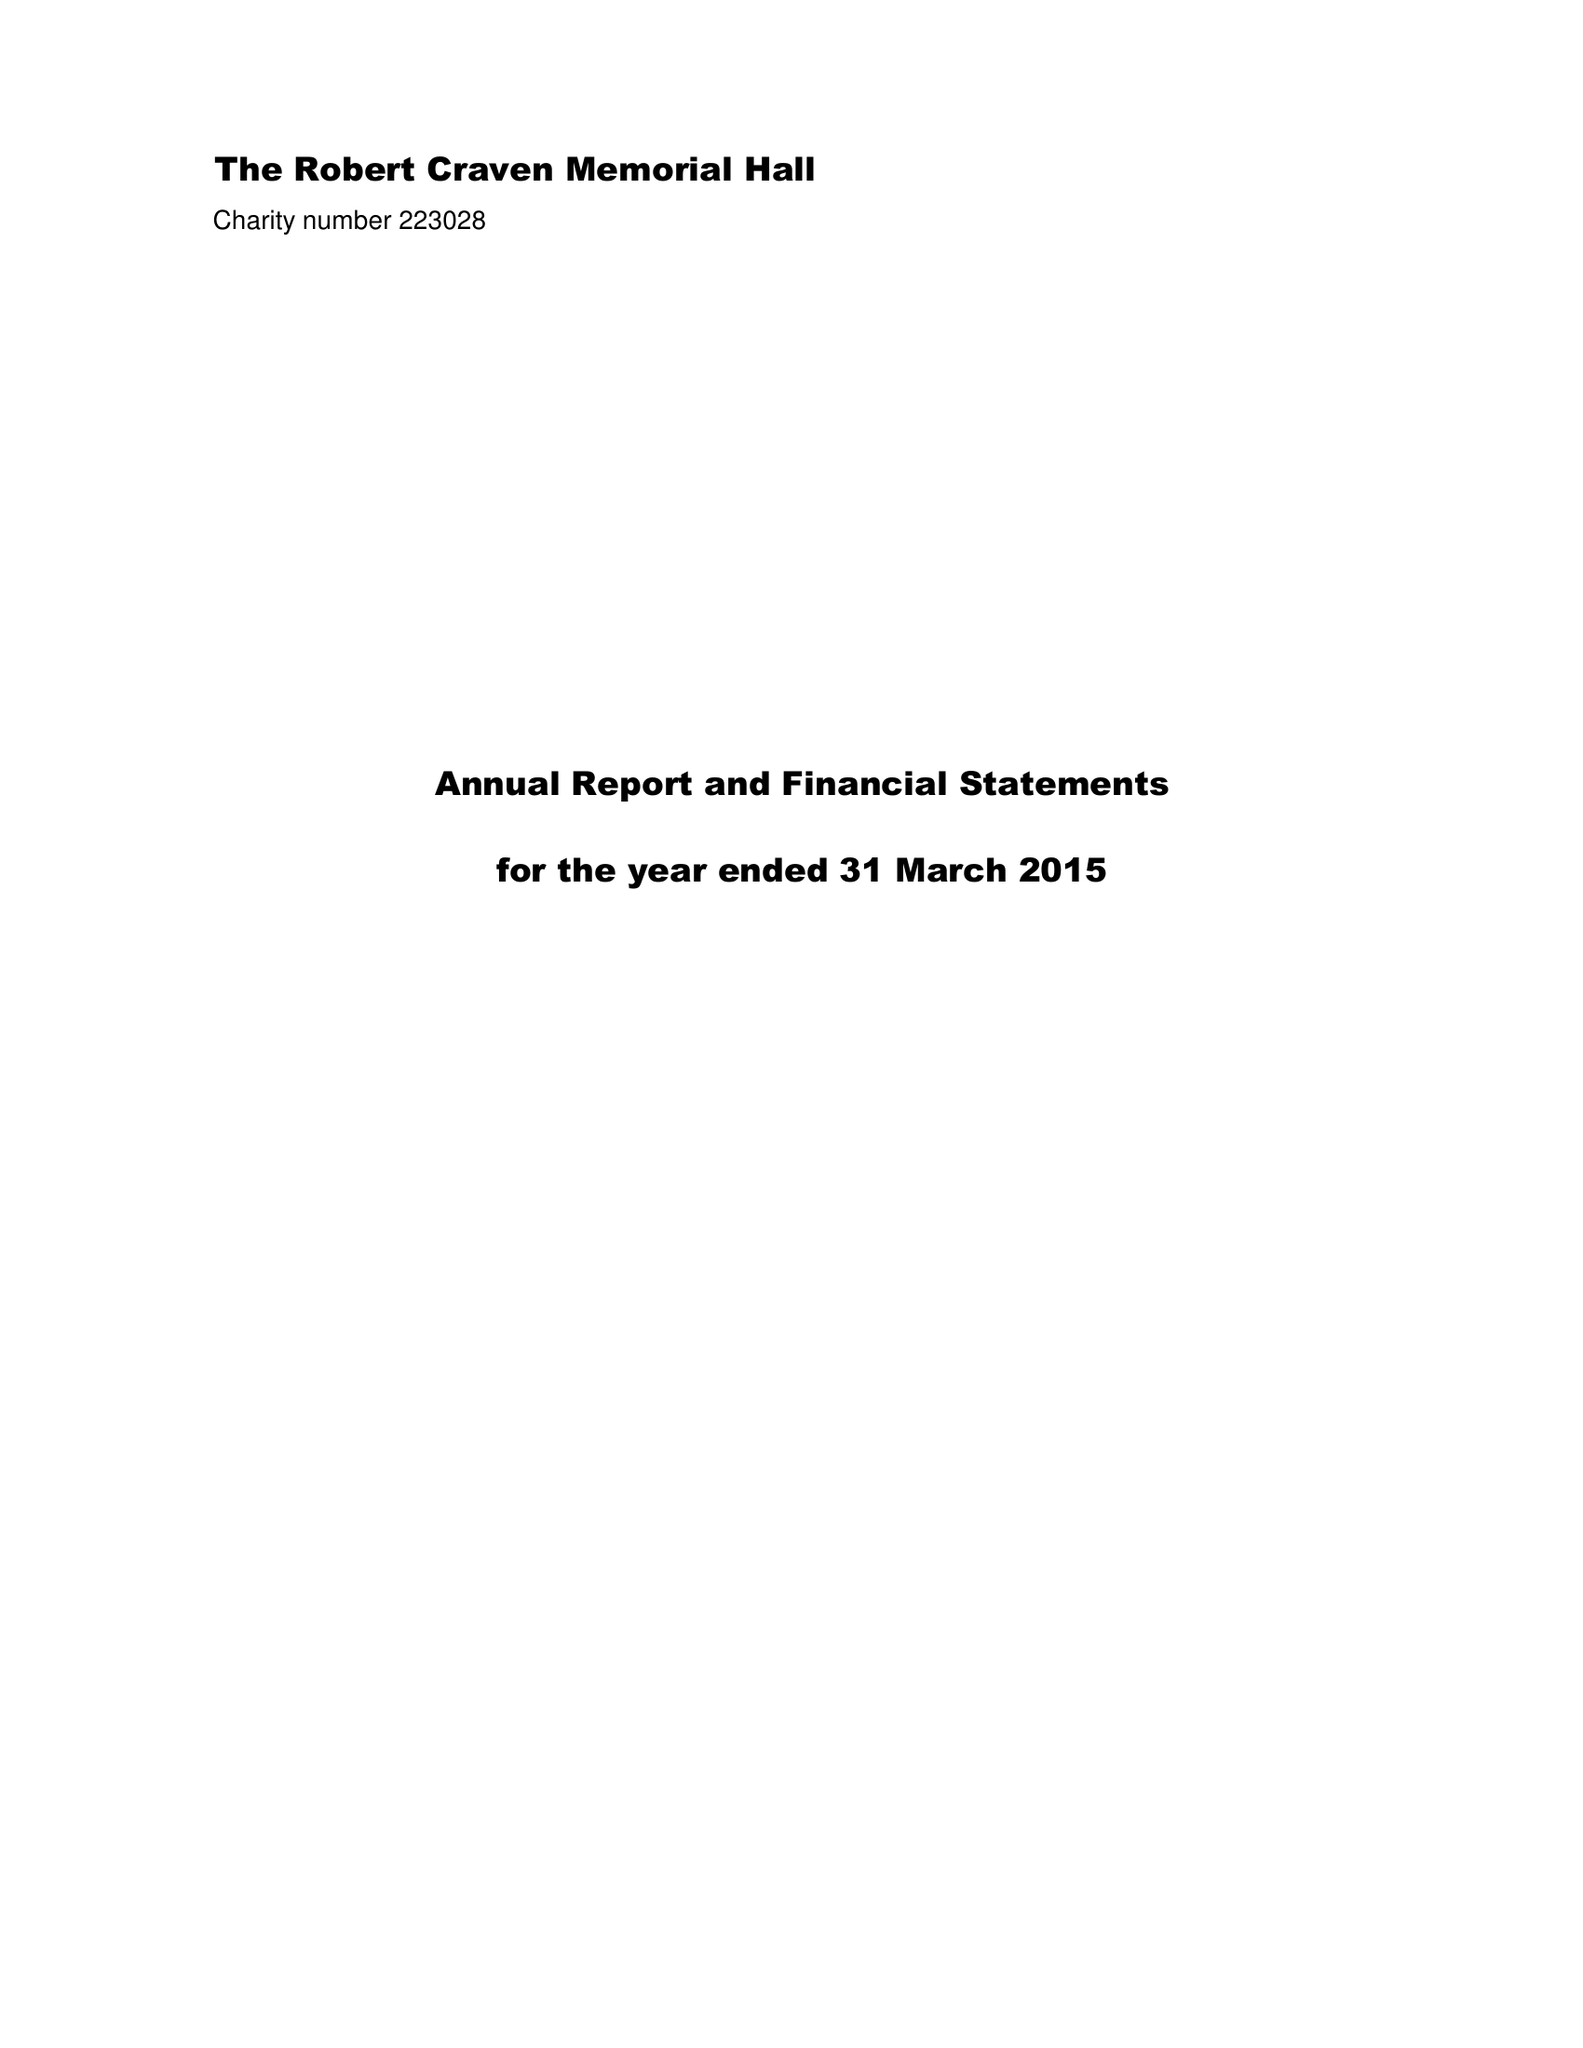What is the value for the address__post_town?
Answer the question using a single word or phrase. LEEDS 